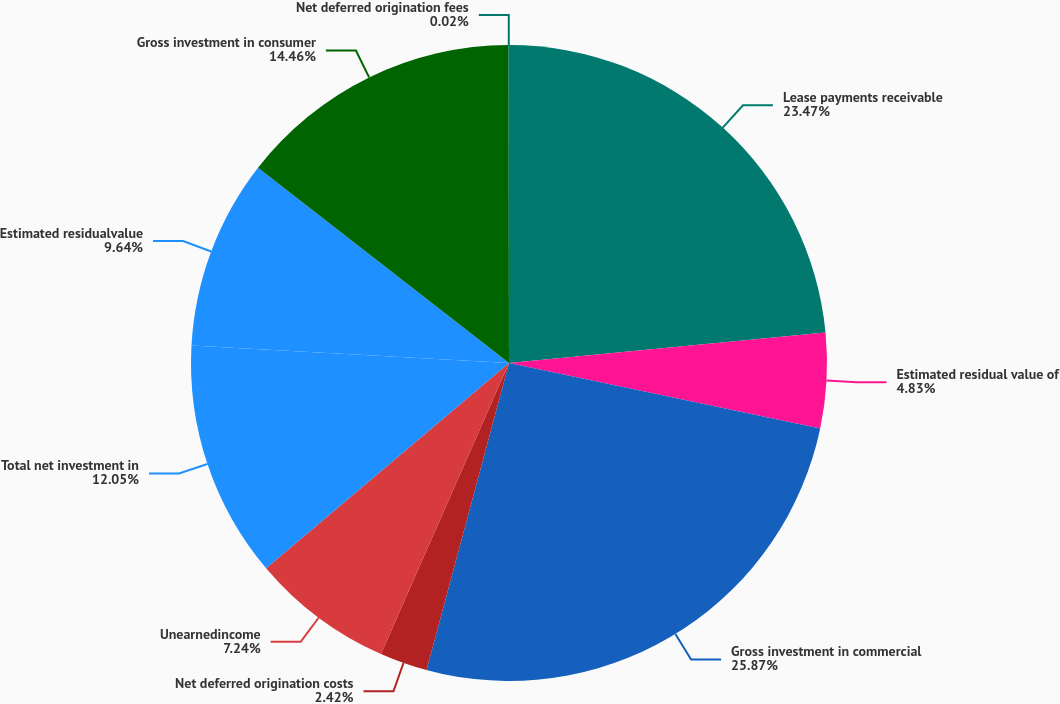<chart> <loc_0><loc_0><loc_500><loc_500><pie_chart><fcel>Lease payments receivable<fcel>Estimated residual value of<fcel>Gross investment in commercial<fcel>Net deferred origination costs<fcel>Unearnedincome<fcel>Total net investment in<fcel>Estimated residualvalue<fcel>Gross investment in consumer<fcel>Net deferred origination fees<nl><fcel>23.47%<fcel>4.83%<fcel>25.88%<fcel>2.42%<fcel>7.24%<fcel>12.05%<fcel>9.64%<fcel>14.46%<fcel>0.02%<nl></chart> 